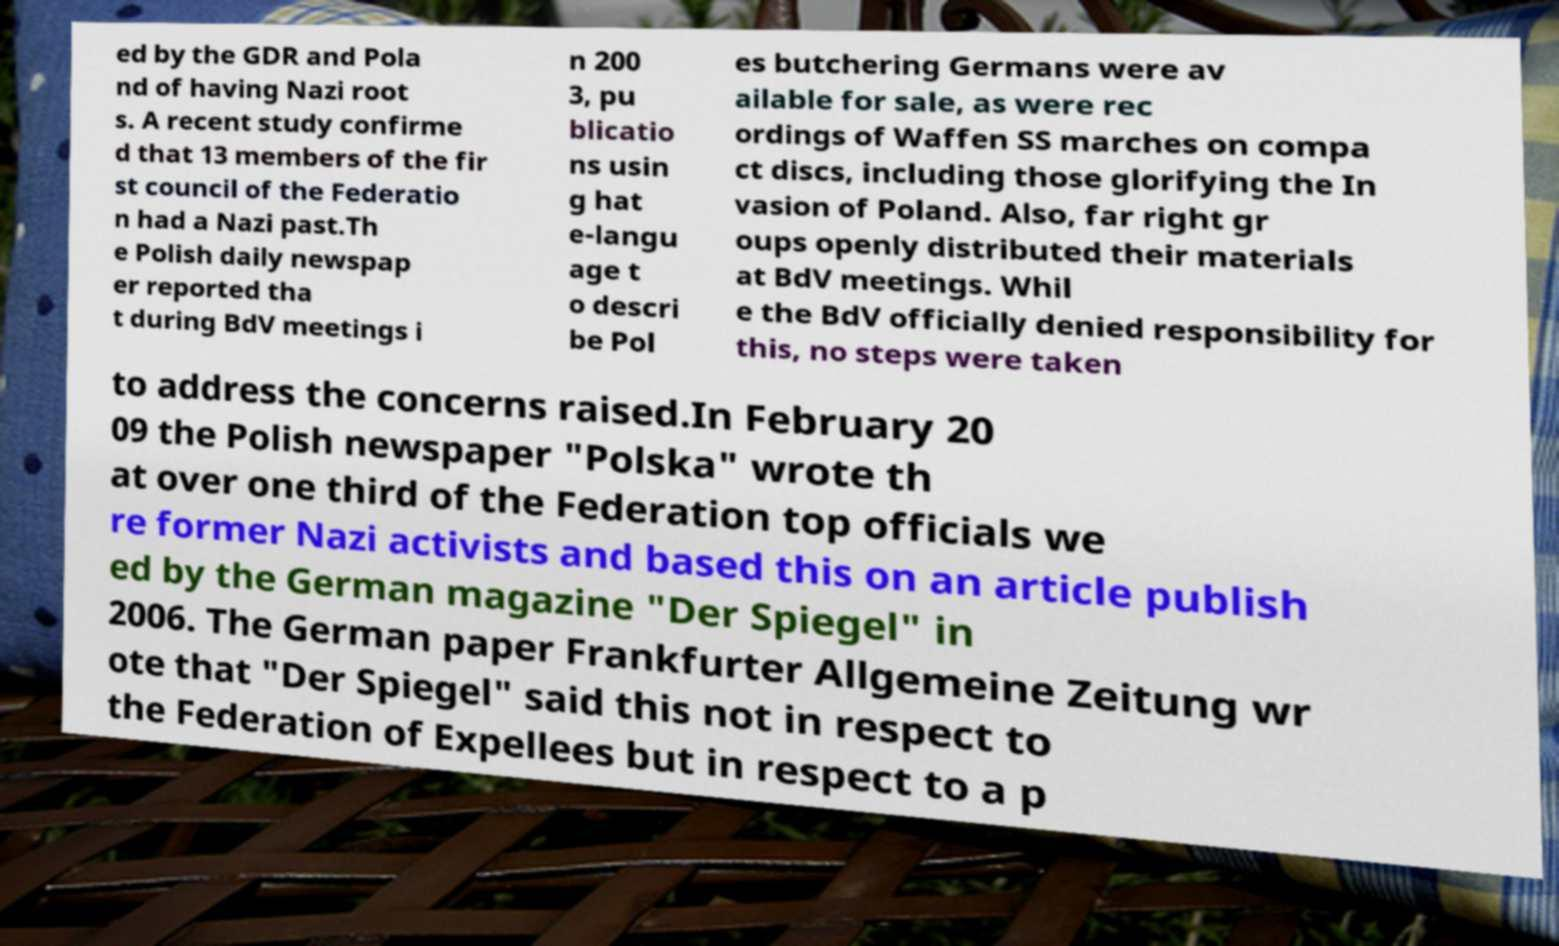I need the written content from this picture converted into text. Can you do that? ed by the GDR and Pola nd of having Nazi root s. A recent study confirme d that 13 members of the fir st council of the Federatio n had a Nazi past.Th e Polish daily newspap er reported tha t during BdV meetings i n 200 3, pu blicatio ns usin g hat e-langu age t o descri be Pol es butchering Germans were av ailable for sale, as were rec ordings of Waffen SS marches on compa ct discs, including those glorifying the In vasion of Poland. Also, far right gr oups openly distributed their materials at BdV meetings. Whil e the BdV officially denied responsibility for this, no steps were taken to address the concerns raised.In February 20 09 the Polish newspaper "Polska" wrote th at over one third of the Federation top officials we re former Nazi activists and based this on an article publish ed by the German magazine "Der Spiegel" in 2006. The German paper Frankfurter Allgemeine Zeitung wr ote that "Der Spiegel" said this not in respect to the Federation of Expellees but in respect to a p 